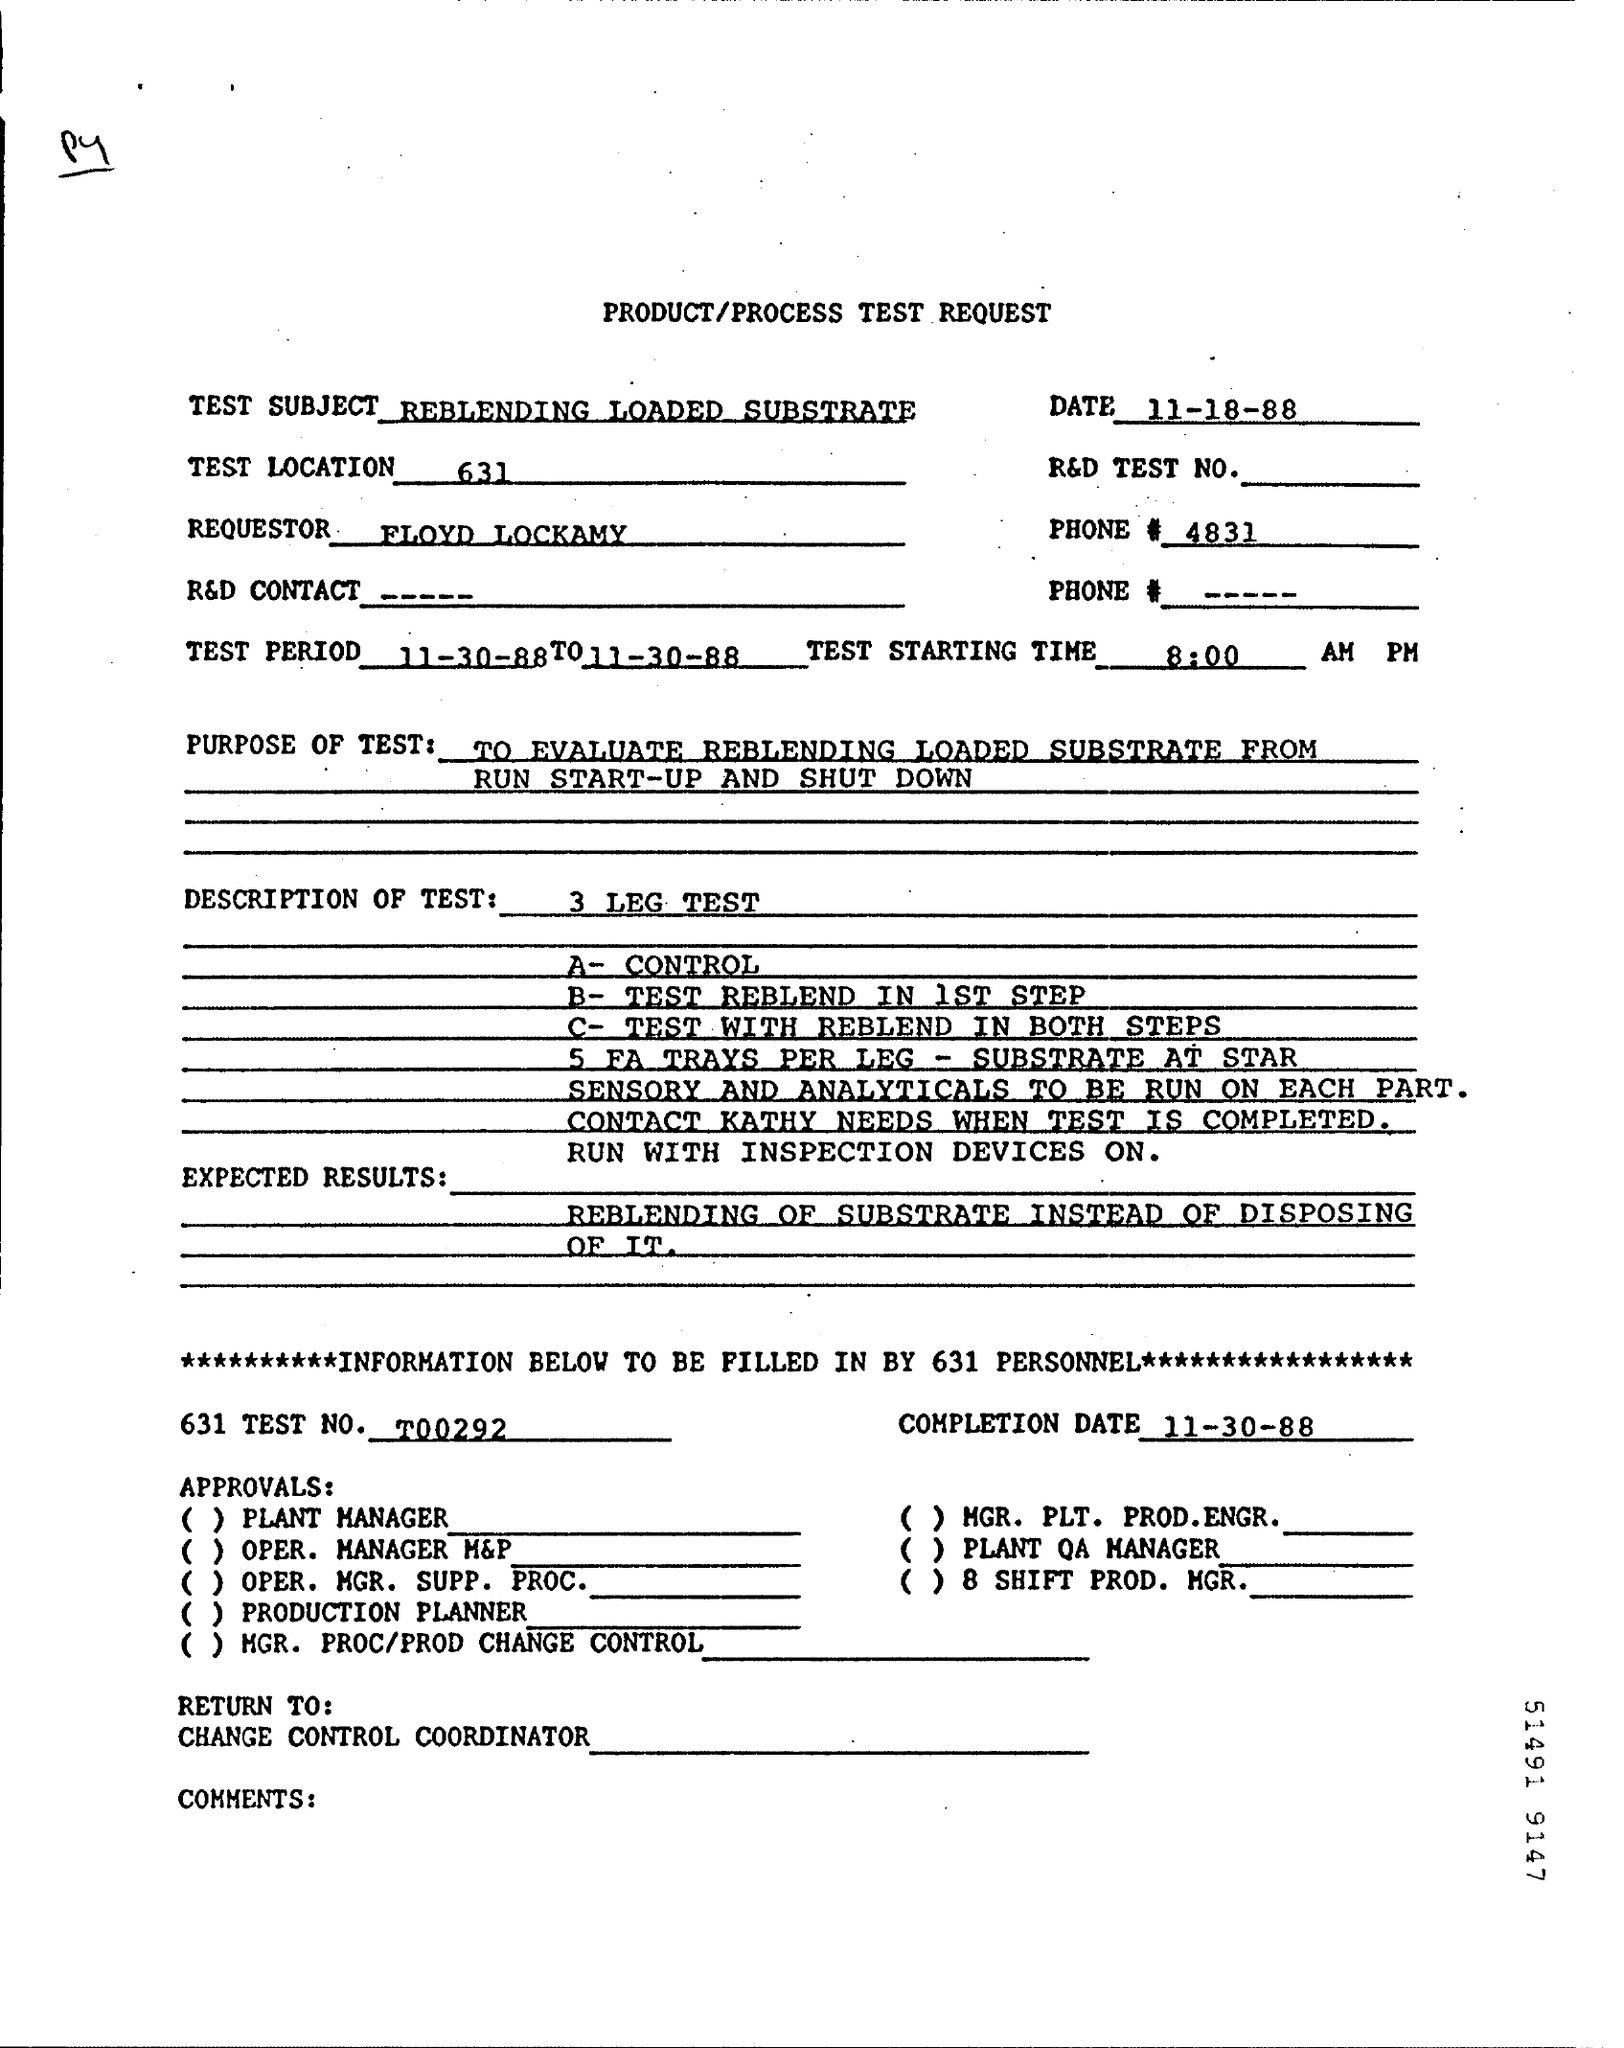What is the Subject of test request
Offer a terse response. REBLENDING LOADED SUBSTRATE. What  Dated  test requested
Offer a terse response. 11-18-88. Who is the Requester
Give a very brief answer. FLOYD LOCKAMY. What is the test Location given
Provide a short and direct response. 631. What is the test Starting Time given in form
Make the answer very short. 8:00 AM PH. 